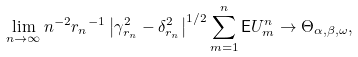<formula> <loc_0><loc_0><loc_500><loc_500>\lim _ { n \to \infty } n ^ { - 2 } { r _ { n } } ^ { - 1 } \left | \gamma _ { r _ { n } } ^ { 2 } - \delta _ { r _ { n } } ^ { 2 } \right | ^ { 1 / 2 } \sum _ { m = 1 } ^ { n } { \mathsf E } U _ { m } ^ { n } \to \Theta _ { \alpha , \beta , \omega } ,</formula> 